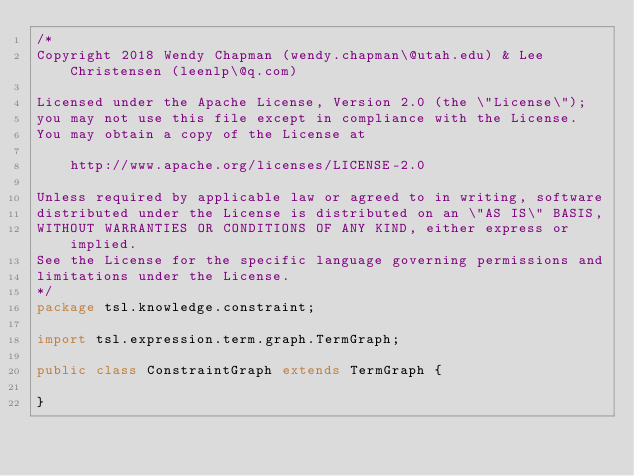<code> <loc_0><loc_0><loc_500><loc_500><_Java_>/*
Copyright 2018 Wendy Chapman (wendy.chapman\@utah.edu) & Lee Christensen (leenlp\@q.com)

Licensed under the Apache License, Version 2.0 (the \"License\");
you may not use this file except in compliance with the License.
You may obtain a copy of the License at

    http://www.apache.org/licenses/LICENSE-2.0

Unless required by applicable law or agreed to in writing, software
distributed under the License is distributed on an \"AS IS\" BASIS,
WITHOUT WARRANTIES OR CONDITIONS OF ANY KIND, either express or implied.
See the License for the specific language governing permissions and
limitations under the License.
*/
package tsl.knowledge.constraint;

import tsl.expression.term.graph.TermGraph;

public class ConstraintGraph extends TermGraph {

}
</code> 